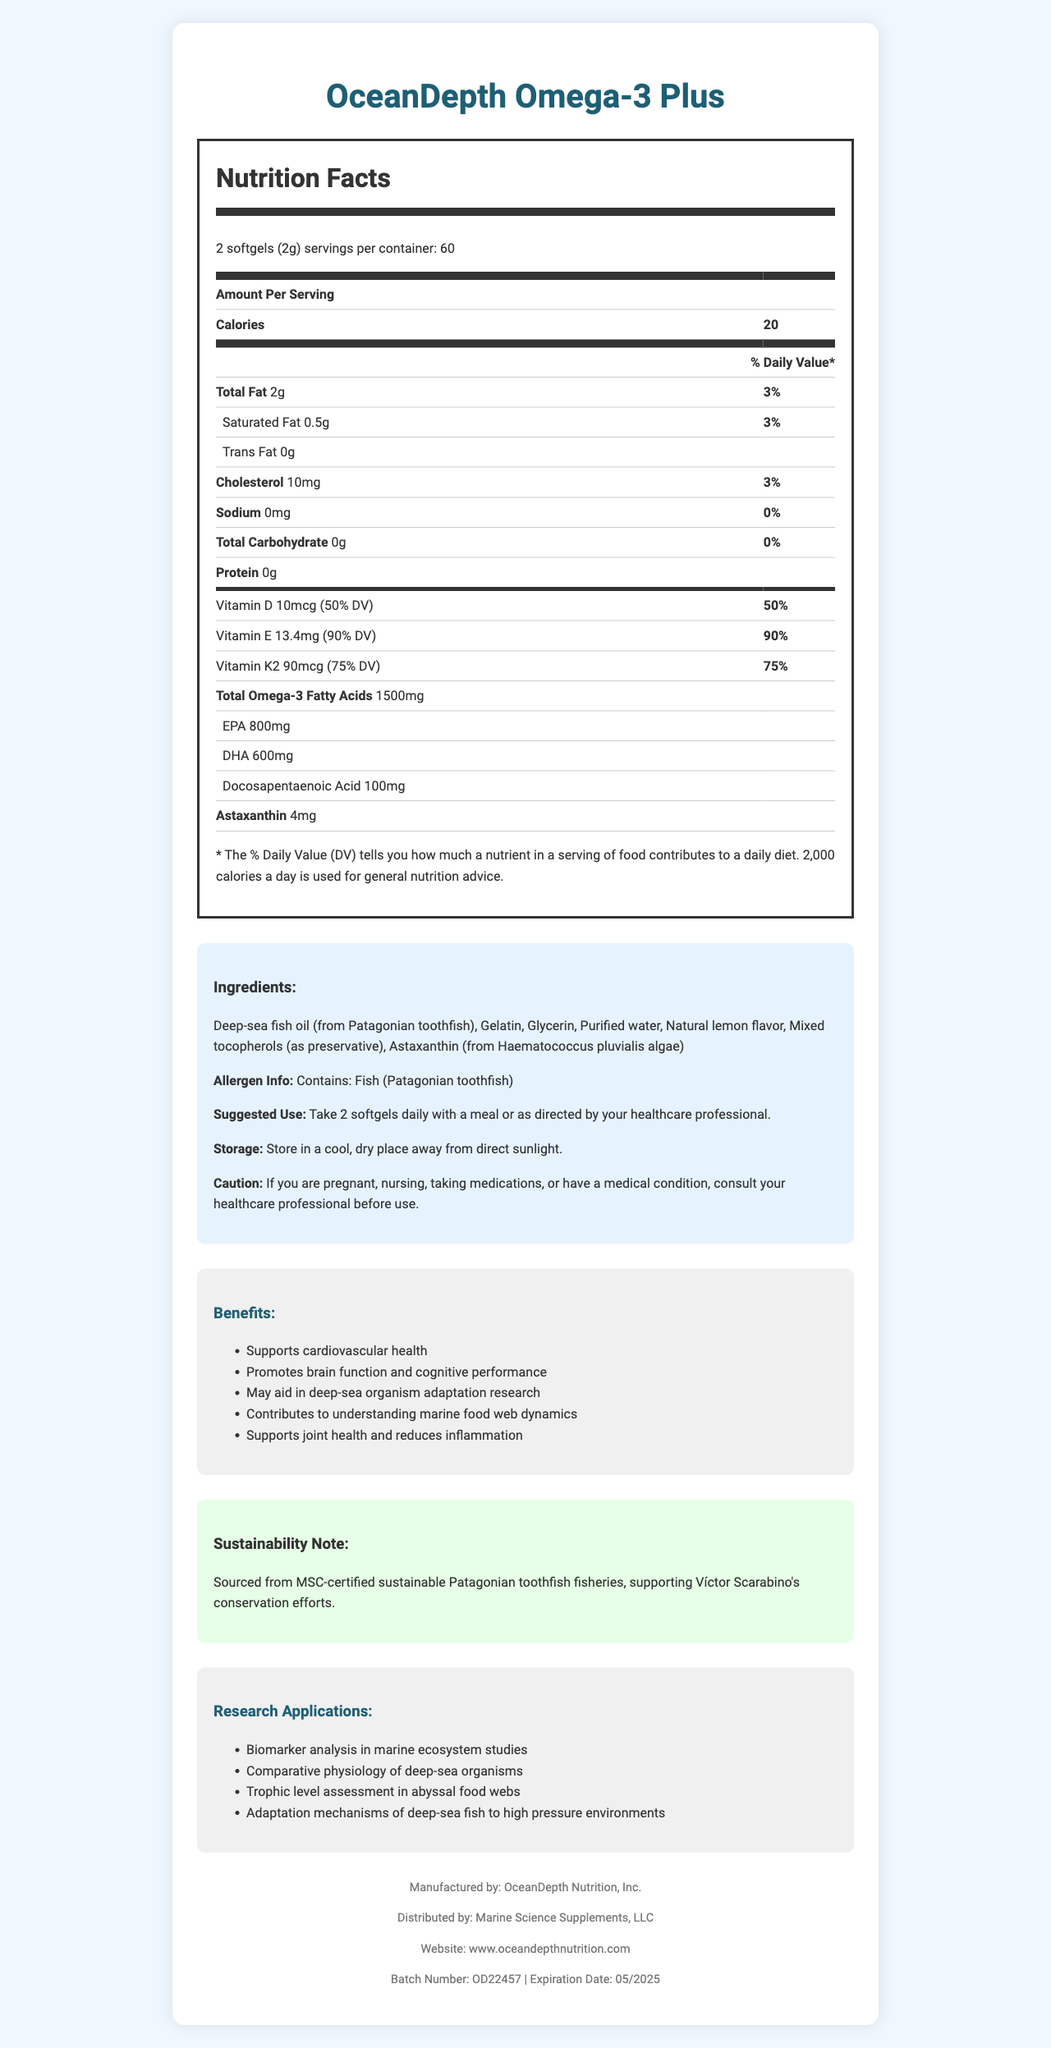what is the serving size for OceanDepth Omega-3 Plus? According to the nutrition facts, the serving size listed is "2 softgels (2g)".
Answer: 2 softgels (2g) how many calories are there per serving? The nutrition facts table indicates that each serving contains 20 calories.
Answer: 20 what are the main ingredients in OceanDepth Omega-3 Plus? The ingredients list provided in the document includes all these components.
Answer: Deep-sea fish oil (from Patagonian toothfish), Gelatin, Glycerin, Purified water, Natural lemon flavor, Mixed tocopherols (as preservative), Astaxanthin (from Haematococcus pluvialis algae) which vitamin has the highest daily value percentage in a serving of OceanDepth Omega-3 Plus? Among the vitamins listed, Vitamin E has a 90% daily value, which is the highest.
Answer: Vitamin E (90% DV) how much DHA is present per serving? The nutrition facts details indicate that DHA per serving is 600mg.
Answer: 600mg which component in OceanDepth Omega-3 Plus is sourced from algae? A. EPA B. Astaxanthin C. Vitamin K2 D. Gelatin Astaxanthin is sourced from Haematococcus pluvialis algae as indicated in the ingredients list.
Answer: B what is a primary benefit of OceanDepth Omega-3 Plus related to research applications? A. Supports joint health B. Biomarker analysis in marine ecosystem studies C. Promotes cardiovascular health Biomarker analysis in marine ecosystem studies is listed under research applications, whereas A and C are listed under general benefits.
Answer: B does OceanDepth Omega-3 Plus contain any carbohydrates? The nutrition facts table clearly states that the total carbohydrate content per serving is 0g.
Answer: No is this product compatible with vegetarian diets? The product contains gelatin and fish oil (from Patagonian toothfish), making it unsuitable for vegetarian diets.
Answer: No summarize the main benefits and applications of OceanDepth Omega-3 Plus as indicated in the document. The document outlines both general health benefits like cardiovascular support and brain function enhancement, and specialized research applications like biomarker analysis. It also highlights the product's sustainability.
Answer: OceanDepth Omega-3 Plus primarily supports cardiovascular health, brain function, joint health, and may assist in deep-sea organism adaptation research. It also provides benefits for marine ecosystem studies, including biomarker analysis and trophic level assessment. The product is sourced sustainably, supporting conservation efforts. who is the main manufacturer of OceanDepth Omega-3 Plus? The footer of the document specifies that OceanDepth Nutrition, Inc. is the manufacturer.
Answer: OceanDepth Nutrition, Inc. what role does Víctor Scarabino's conservation efforts play in the product's sustainability? By ensuring the fish oil is sourced from sustainable fisheries, the product aligns with conservation efforts championed by Víctor Scarabino.
Answer: The product supports Víctor Scarabino's conservation efforts through sourcing from MSC-certified sustainable Patagonian toothfish fisheries. how many servings are there in one container of OceanDepth Omega-3 Plus? The nutrition facts highlight that each container contains 60 servings.
Answer: 60 what is the recommended storage condition for OceanDepth Omega-3 Plus? The document advises storing the product in a cool, dry place away from direct sunlight.
Answer: Store in a cool, dry place away from direct sunlight. what could be a reason to consult a healthcare professional before using OceanDepth Omega-3 Plus? The caution section advises consulting a healthcare professional under these circumstances.
Answer: If you are pregnant, nursing, taking medications, or have a medical condition how is the daily value percentage (%) for Vitamin D compared to Vitamin E in OceanDepth Omega-3 Plus? The document shows that Vitamin D contributes 50% of the daily value and Vitamin E contributes 90%.
Answer: Vitamin D has 50% DV while Vitamin E has 90% DV how can this product aid in deep-sea organism adaptation research? The benefits and research applications sections highlight that the product may aid in understanding how deep-sea organisms adapt to extreme environments.
Answer: It may aid in the study of mechanisms that allow deep-sea fish to adapt to high pressure environments what is the batch number of OceanDepth Omega-3 Plus? The footer of the document displays the batch number as OD22457.
Answer: OD22457 what is the specific source of the fish oil in OceanDepth Omega-3 Plus? The ingredients section lists deep-sea fish oil sourced from Patagonian toothfish.
Answer: Patagonian toothfish what is the flavoring added to OceanDepth Omega-3 Plus? A. Strawberry B. Cherry C. Lemon D. Mint The ingredients list mentions "Natural lemon flavor" as the added flavor.
Answer: C does the nutrition facts label list the amount of protein in the supplement? The nutrition facts table includes "Protein" listed at 0g per serving.
Answer: Yes, it is listed as 0g per serving. can you determine the exact marine conservation project Víctor Scarabino is involved with from this document? While the document mentions Scarabino's conservation efforts, it does not detail specific projects.
Answer: No, the document does not provide specific details about the conservation projects. 